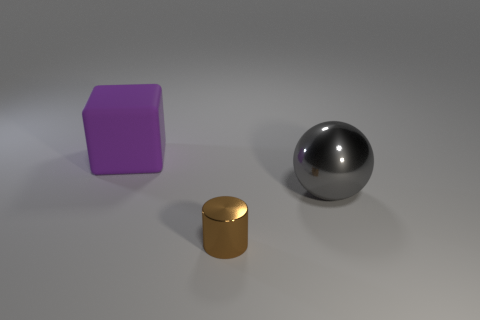Subtract all cubes. How many objects are left? 2 Add 3 large purple matte things. How many objects exist? 6 Add 3 small metal things. How many small metal things exist? 4 Subtract 0 green balls. How many objects are left? 3 Subtract 1 spheres. How many spheres are left? 0 Subtract all green spheres. Subtract all green cylinders. How many spheres are left? 1 Subtract all shiny spheres. Subtract all small brown metallic cylinders. How many objects are left? 1 Add 3 small metal objects. How many small metal objects are left? 4 